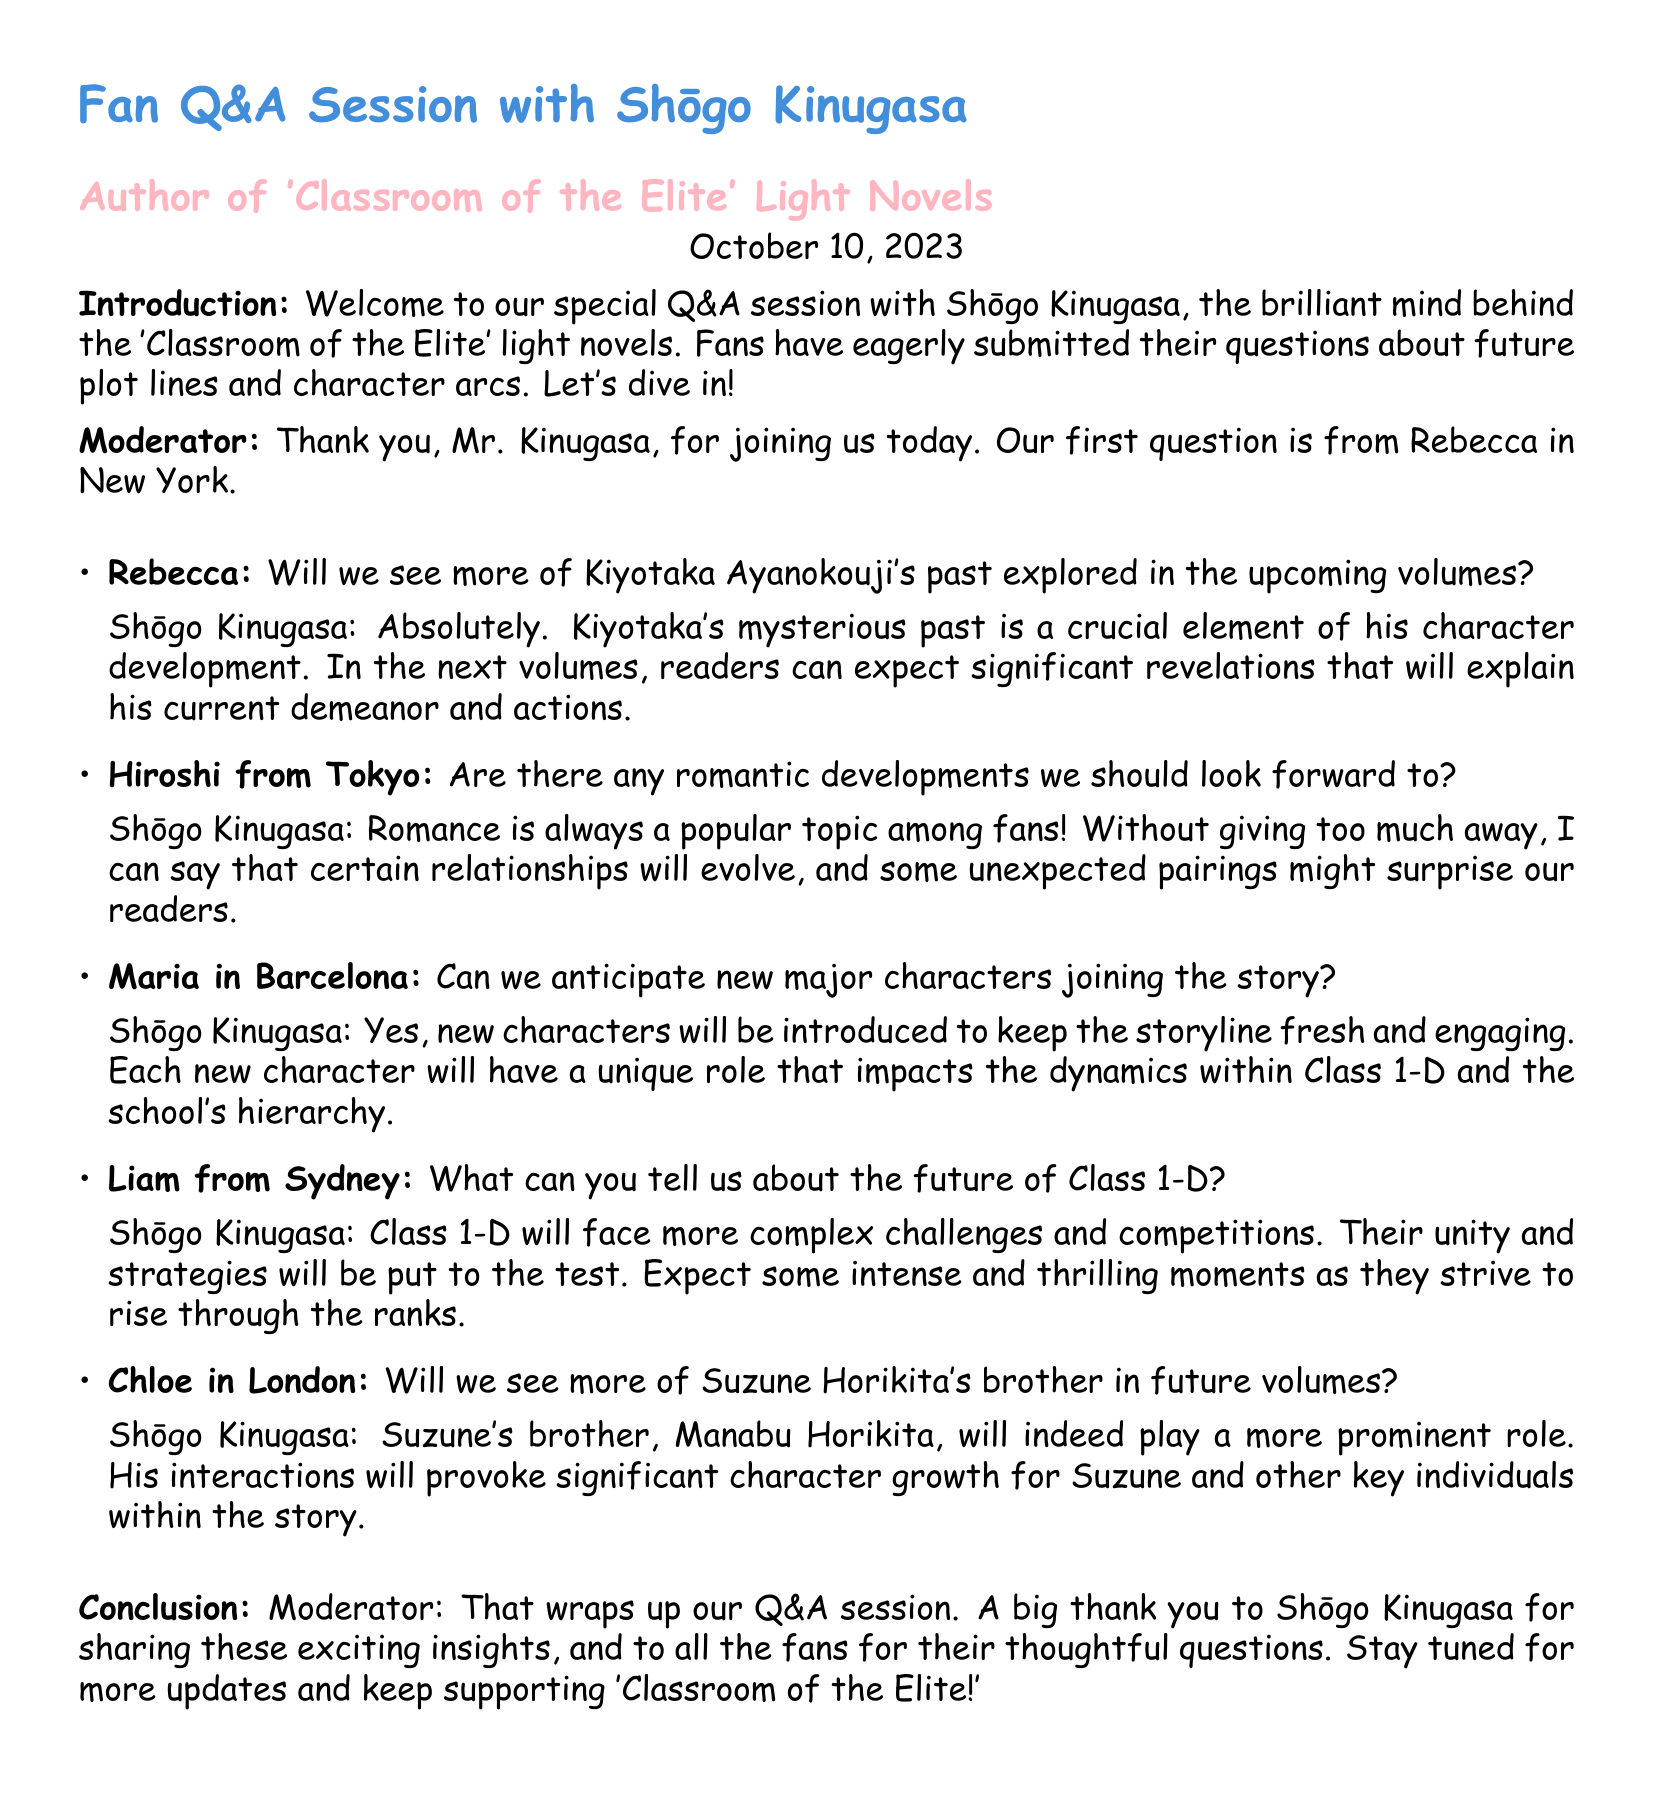What date was the fan Q&A session held? The document states the date of the session as October 10, 2023.
Answer: October 10, 2023 Who is the author of 'Classroom of the Elite'? The transcript identifies Shōgo Kinugasa as the author of the light novels.
Answer: Shōgo Kinugasa What character's past will be explored in the upcoming volumes? The document mentions Kiyotaka Ayanokouji's past will be explored further.
Answer: Kiyotaka Ayanokouji Will romantic developments be included in future volumes? The author confirms that there will be romantic developments in the upcoming plots.
Answer: Yes Which class will face complex challenges in the future? The transcript states that Class 1-D will confront more complex challenges.
Answer: Class 1-D What role will Manabu Horikita play in future volumes? The document notes that Manabu Horikita will play a more prominent role and influence other characters.
Answer: More prominent role How did the moderator conclude the Q&A session? The moderator wraps up by thanking the author and fans for their participation.
Answer: Thanking the author and fans What type of new characters can we expect? The transcript indicates that new characters will be introduced with unique roles.
Answer: New characters with unique roles 